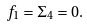Convert formula to latex. <formula><loc_0><loc_0><loc_500><loc_500>f _ { 1 } = \Sigma _ { 4 } = 0 .</formula> 